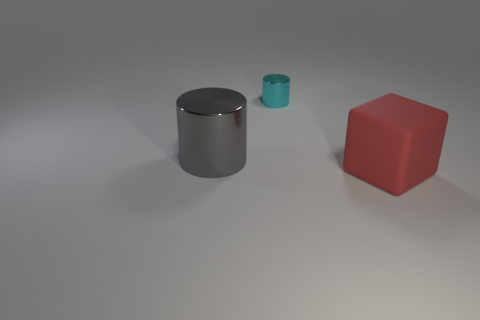Add 2 large metallic things. How many objects exist? 5 Subtract all cubes. How many objects are left? 2 Subtract all brown metallic cubes. Subtract all large gray cylinders. How many objects are left? 2 Add 1 metallic cylinders. How many metallic cylinders are left? 3 Add 1 small yellow cylinders. How many small yellow cylinders exist? 1 Subtract 0 red spheres. How many objects are left? 3 